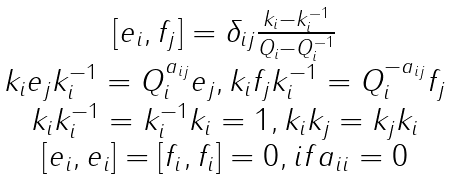Convert formula to latex. <formula><loc_0><loc_0><loc_500><loc_500>\begin{array} { c } { { [ e _ { i } , f _ { j } ] = \delta _ { i j } \frac { k _ { i } - k _ { i } ^ { - 1 } } { Q _ { i } - Q _ { i } ^ { - 1 } } } } \\ { { k _ { i } e _ { j } k _ { i } ^ { - 1 } = Q _ { i } ^ { a _ { i j } } e _ { j } , k _ { i } f _ { j } k _ { i } ^ { - 1 } = Q _ { i } ^ { - a _ { i j } } f _ { j } } } \\ { { k _ { i } k _ { i } ^ { - 1 } = k _ { i } ^ { - 1 } k _ { i } = 1 , k _ { i } k _ { j } = k _ { j } k _ { i } } } \\ { { [ e _ { i } , e _ { i } ] = [ f _ { i } , f _ { i } ] = 0 , i f a _ { i i } = 0 } } \end{array}</formula> 